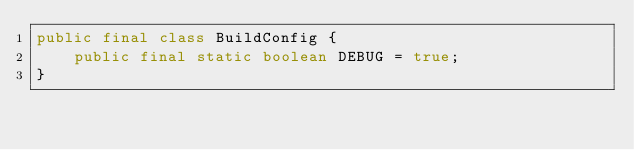<code> <loc_0><loc_0><loc_500><loc_500><_Java_>public final class BuildConfig {
    public final static boolean DEBUG = true;
}</code> 